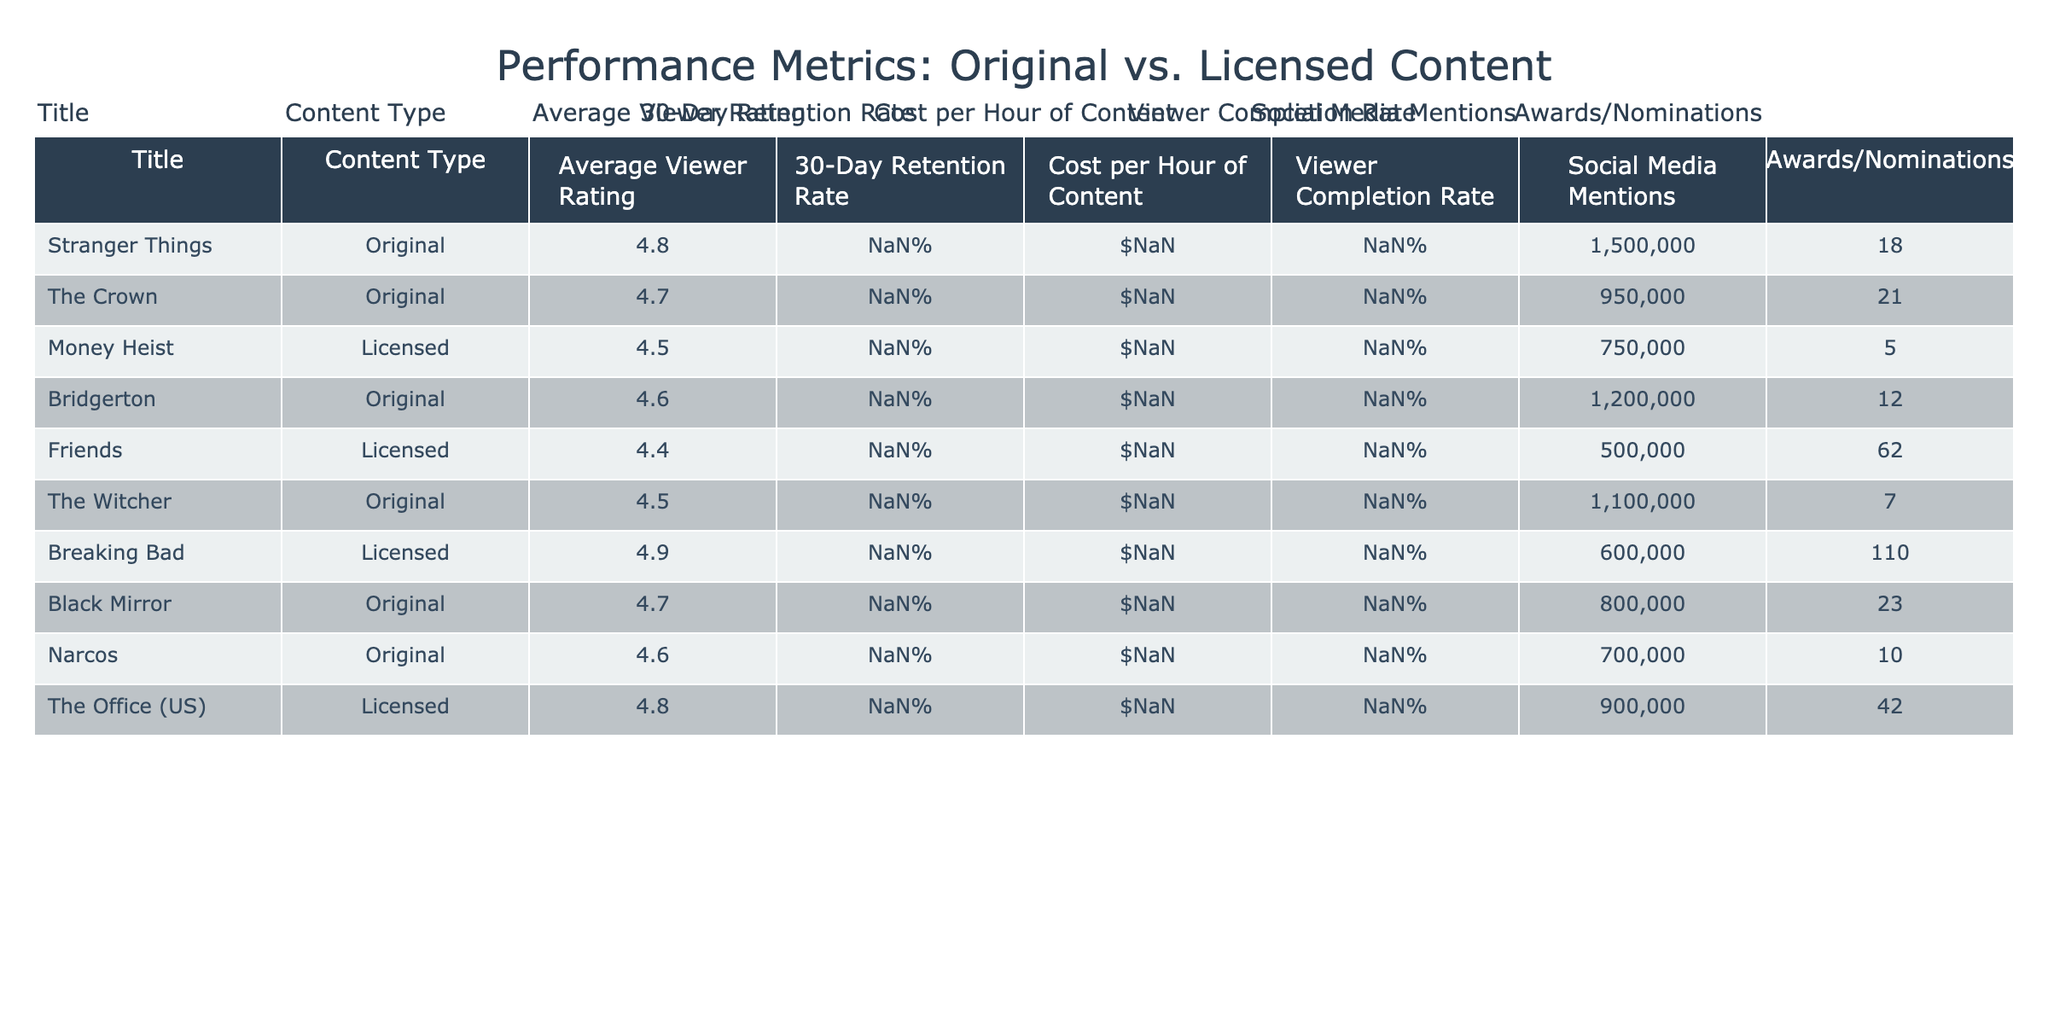What's the average viewer rating for Original content? The table shows viewer ratings for all Original titles: 4.8 (Stranger Things), 4.7 (The Crown), 4.6 (Bridgerton), 4.5 (The Witcher), 4.7 (Black Mirror), and 4.6 (Narcos). To find the average, sum these ratings: 4.8 + 4.7 + 4.6 + 4.5 + 4.7 + 4.6 = 27.4. There are 6 titles, so the average rating is 27.4 / 6 = 4.57.
Answer: 4.57 Which content type has the highest social media mentions? The table lists social media mentions for all titles: 1,500,000 (Stranger Things), 950,000 (The Crown), 750,000 (Money Heist), 1,200,000 (Bridgerton), 500,000 (Friends), 1,100,000 (The Witcher), 600,000 (Breaking Bad), 800,000 (Black Mirror), 700,000 (Narcos), and 900,000 (The Office). The highest value is 1,500,000 for Stranger Things, which is an Original content.
Answer: Stranger Things Is the average 30-day retention rate for Licensed content higher than for Original content? The table shows the 30-day retention rates: Original content has rates of 78% (Stranger Things), 72% (The Crown), 70% (Bridgerton), 68% (The Witcher), 71% (Black Mirror), and 67% (Narcos), totaling 426%. This gives an average of 426% / 6 = 71%. For Licensed content: 65% (Money Heist), 60% (Friends), 75% (Breaking Bad), and 82% (The Office) totals 282%, with an average of 282% / 4 = 70.5%. 71% (Original) is higher than 70.5% (Licensed).
Answer: Yes What is the total cost per hour of content for all Licensed titles? The table provides costs for all Licensed titles: $2,000,000 (Money Heist), $1,000,000 (Friends), $3,000,000 (Breaking Bad), and $1,500,000 (The Office). Summing these amounts gives: 2,000,000 + 1,000,000 + 3,000,000 + 1,500,000 = 7,500,000.
Answer: 7,500,000 Which Original title has the best viewer completion rate? Looking at the viewer completion rates for original titles: 92% (Stranger Things), 88% (The Crown), 90% (Bridgerton), 87% (The Witcher), 89% (Black Mirror), and 86% (Narcos). The highest value is 92% for Stranger Things.
Answer: Stranger Things 